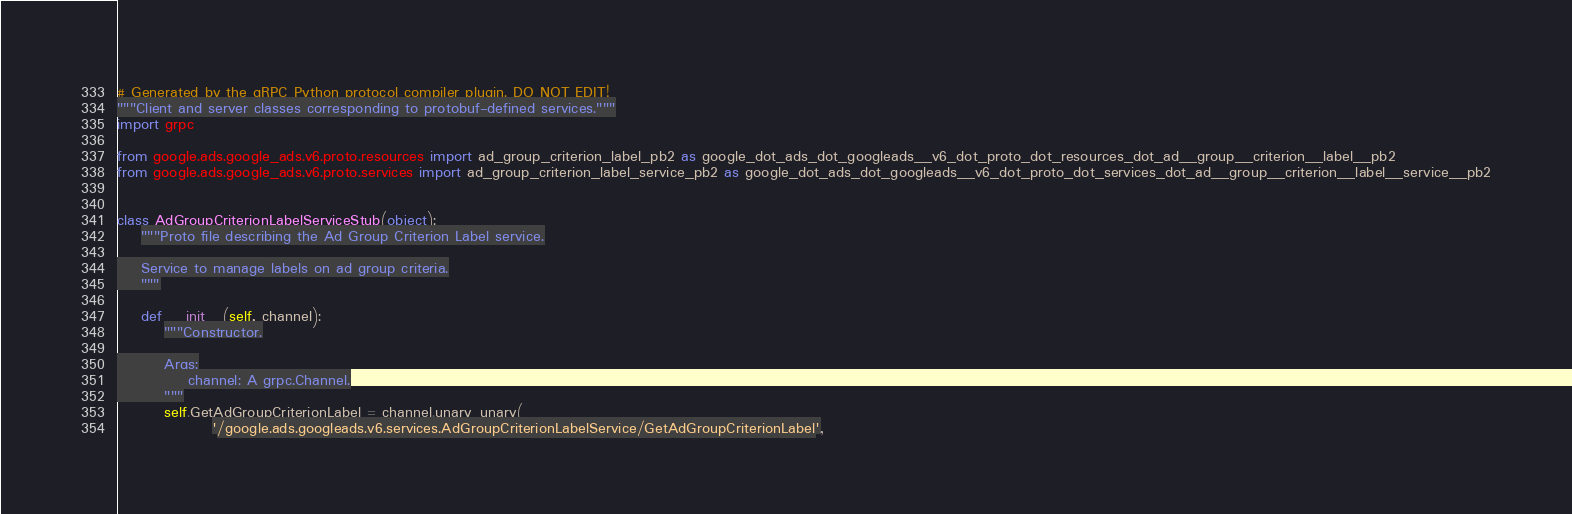<code> <loc_0><loc_0><loc_500><loc_500><_Python_># Generated by the gRPC Python protocol compiler plugin. DO NOT EDIT!
"""Client and server classes corresponding to protobuf-defined services."""
import grpc

from google.ads.google_ads.v6.proto.resources import ad_group_criterion_label_pb2 as google_dot_ads_dot_googleads__v6_dot_proto_dot_resources_dot_ad__group__criterion__label__pb2
from google.ads.google_ads.v6.proto.services import ad_group_criterion_label_service_pb2 as google_dot_ads_dot_googleads__v6_dot_proto_dot_services_dot_ad__group__criterion__label__service__pb2


class AdGroupCriterionLabelServiceStub(object):
    """Proto file describing the Ad Group Criterion Label service.

    Service to manage labels on ad group criteria.
    """

    def __init__(self, channel):
        """Constructor.

        Args:
            channel: A grpc.Channel.
        """
        self.GetAdGroupCriterionLabel = channel.unary_unary(
                '/google.ads.googleads.v6.services.AdGroupCriterionLabelService/GetAdGroupCriterionLabel',</code> 